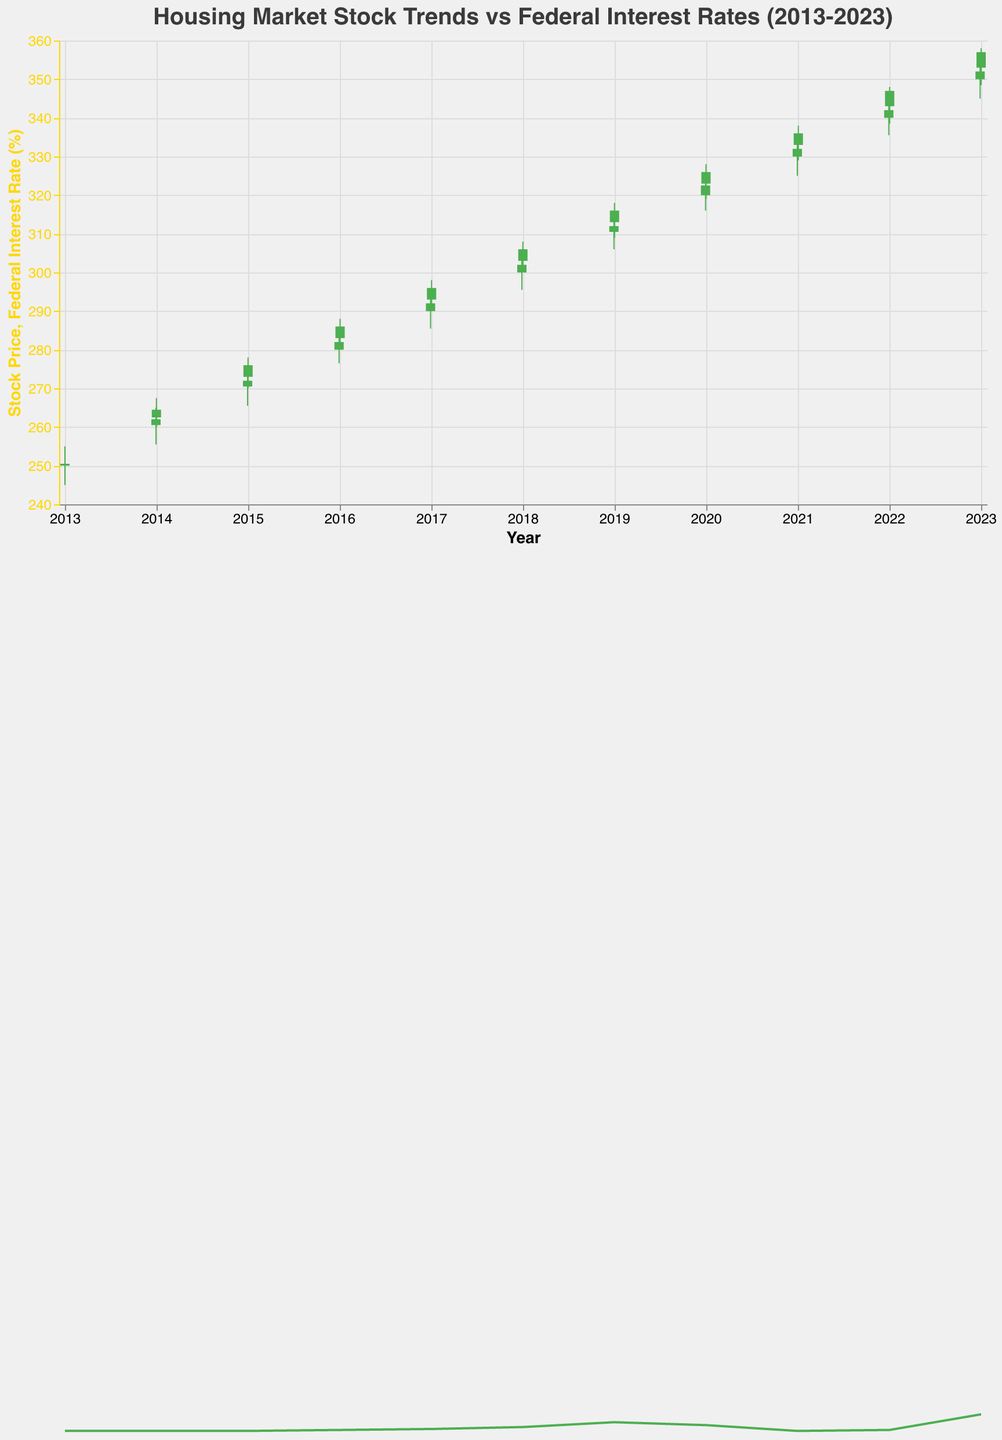What is the title of the figure? The title is displayed at the top center of the chart in a larger font size.
Answer: Housing Market Stock Trends vs Federal Interest Rates (2013-2023) How many unique data points are represented in the figure? Each candlestick represents a unique data point. Count the number of candlesticks present in the figure.
Answer: 20 What color is used to mark a stock price increase, where the closing price is higher than the opening price? The color for a stock price increase is consistent throughout the chart and is visually distinct from the color used for a decrease.
Answer: Green What was the Federal Interest Rate at the start of the year 2018? Find the candlestick corresponding to January 2018 and look for the Federal Interest Rate value.
Answer: 1.25% What date had the highest closing stock price and what was that price? Identify the candlestick with the highest closing value and note the corresponding date and price.
Answer: 2022-12-30, $352.00 What was the trend of Federal Interest Rates from 2013 to 2023? Observe the yellow line that indicates Federal Interest Rate values over time, noting increases, decreases, and trends.
Answer: Increasing with fluctuations How does the stock price at the end of 2015 compare to the stock price at the end of 2020? Identify and compare the closing prices of the candlesticks for 2015-12-31 and 2020-12-31.
Answer: End of 2015: $282.00, End of 2020: $332.00, Increase of $50.00 What month and year did the Federal Interest Rate first increase above 2%? Follow the yellow line and identify the first point where the Federal Interest Rate exceeds 2%.
Answer: December 2018 Which year had the smallest gap between the highest and lowest stock prices? Look for the candlestick with the smallest range (difference between high and low values) over the years and note the corresponding date.
Answer: Possibly 2023 (based on provided data) What can you infer about the relationship between Federal Interest Rates and stock prices from the middle of 2022? Analyze the trend of both the stock price and Federal Interest Rate from mid-2022 to infer if there's a correlation between the two.
Answer: Both increased rapidly 